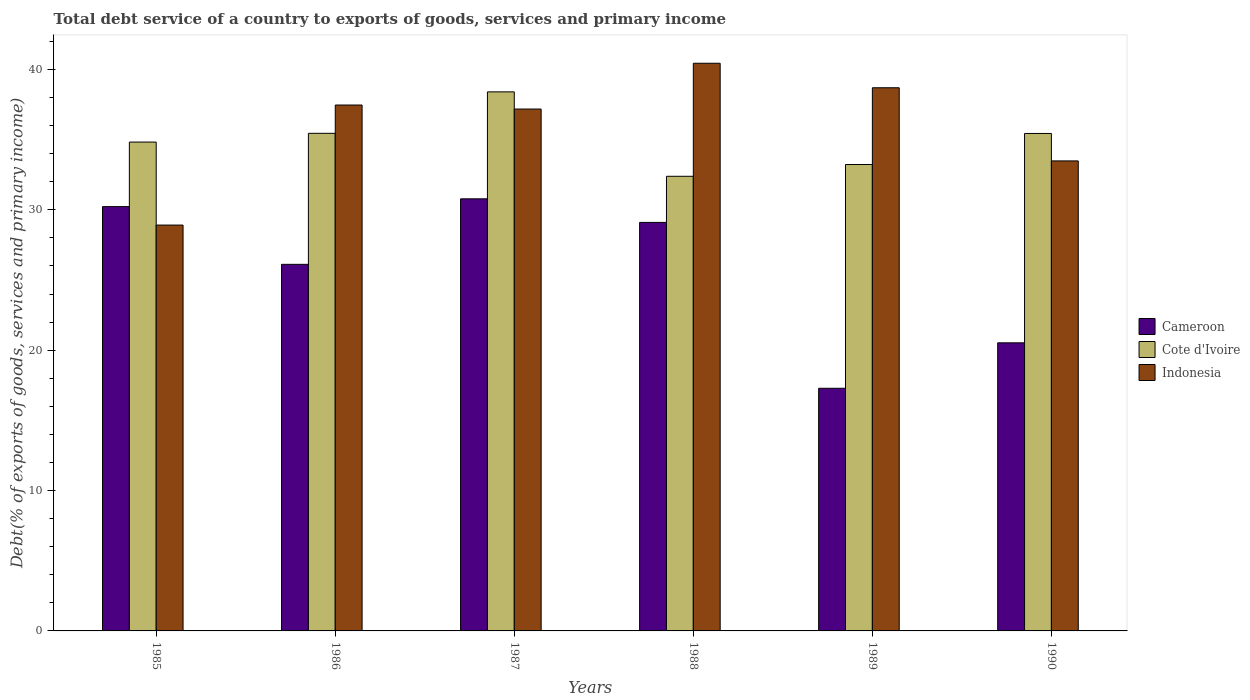How many groups of bars are there?
Your answer should be compact. 6. Are the number of bars per tick equal to the number of legend labels?
Provide a succinct answer. Yes. Are the number of bars on each tick of the X-axis equal?
Provide a short and direct response. Yes. How many bars are there on the 1st tick from the right?
Offer a terse response. 3. What is the total debt service in Indonesia in 1987?
Provide a succinct answer. 37.18. Across all years, what is the maximum total debt service in Cote d'Ivoire?
Your response must be concise. 38.4. Across all years, what is the minimum total debt service in Cameroon?
Offer a very short reply. 17.29. In which year was the total debt service in Cameroon maximum?
Provide a succinct answer. 1987. What is the total total debt service in Indonesia in the graph?
Keep it short and to the point. 216.17. What is the difference between the total debt service in Cameroon in 1985 and that in 1986?
Provide a short and direct response. 4.11. What is the difference between the total debt service in Indonesia in 1987 and the total debt service in Cote d'Ivoire in 1985?
Offer a terse response. 2.35. What is the average total debt service in Indonesia per year?
Provide a succinct answer. 36.03. In the year 1988, what is the difference between the total debt service in Cameroon and total debt service in Indonesia?
Ensure brevity in your answer.  -11.34. What is the ratio of the total debt service in Indonesia in 1986 to that in 1987?
Make the answer very short. 1.01. What is the difference between the highest and the second highest total debt service in Indonesia?
Keep it short and to the point. 1.75. What is the difference between the highest and the lowest total debt service in Cameroon?
Your response must be concise. 13.5. In how many years, is the total debt service in Indonesia greater than the average total debt service in Indonesia taken over all years?
Keep it short and to the point. 4. What does the 1st bar from the left in 1987 represents?
Your answer should be compact. Cameroon. What does the 2nd bar from the right in 1989 represents?
Offer a terse response. Cote d'Ivoire. Is it the case that in every year, the sum of the total debt service in Cote d'Ivoire and total debt service in Cameroon is greater than the total debt service in Indonesia?
Offer a very short reply. Yes. What is the difference between two consecutive major ticks on the Y-axis?
Offer a very short reply. 10. Does the graph contain any zero values?
Your response must be concise. No. Where does the legend appear in the graph?
Your response must be concise. Center right. What is the title of the graph?
Offer a very short reply. Total debt service of a country to exports of goods, services and primary income. Does "Venezuela" appear as one of the legend labels in the graph?
Keep it short and to the point. No. What is the label or title of the Y-axis?
Your answer should be compact. Debt(% of exports of goods, services and primary income). What is the Debt(% of exports of goods, services and primary income) of Cameroon in 1985?
Provide a short and direct response. 30.23. What is the Debt(% of exports of goods, services and primary income) in Cote d'Ivoire in 1985?
Keep it short and to the point. 34.82. What is the Debt(% of exports of goods, services and primary income) in Indonesia in 1985?
Your response must be concise. 28.91. What is the Debt(% of exports of goods, services and primary income) of Cameroon in 1986?
Make the answer very short. 26.11. What is the Debt(% of exports of goods, services and primary income) of Cote d'Ivoire in 1986?
Your response must be concise. 35.45. What is the Debt(% of exports of goods, services and primary income) of Indonesia in 1986?
Offer a very short reply. 37.46. What is the Debt(% of exports of goods, services and primary income) of Cameroon in 1987?
Ensure brevity in your answer.  30.78. What is the Debt(% of exports of goods, services and primary income) of Cote d'Ivoire in 1987?
Your response must be concise. 38.4. What is the Debt(% of exports of goods, services and primary income) in Indonesia in 1987?
Provide a succinct answer. 37.18. What is the Debt(% of exports of goods, services and primary income) in Cameroon in 1988?
Ensure brevity in your answer.  29.1. What is the Debt(% of exports of goods, services and primary income) in Cote d'Ivoire in 1988?
Your response must be concise. 32.39. What is the Debt(% of exports of goods, services and primary income) in Indonesia in 1988?
Your answer should be compact. 40.44. What is the Debt(% of exports of goods, services and primary income) in Cameroon in 1989?
Provide a short and direct response. 17.29. What is the Debt(% of exports of goods, services and primary income) of Cote d'Ivoire in 1989?
Provide a short and direct response. 33.23. What is the Debt(% of exports of goods, services and primary income) of Indonesia in 1989?
Your answer should be very brief. 38.69. What is the Debt(% of exports of goods, services and primary income) in Cameroon in 1990?
Keep it short and to the point. 20.52. What is the Debt(% of exports of goods, services and primary income) in Cote d'Ivoire in 1990?
Make the answer very short. 35.44. What is the Debt(% of exports of goods, services and primary income) of Indonesia in 1990?
Offer a very short reply. 33.48. Across all years, what is the maximum Debt(% of exports of goods, services and primary income) in Cameroon?
Your response must be concise. 30.78. Across all years, what is the maximum Debt(% of exports of goods, services and primary income) in Cote d'Ivoire?
Your answer should be very brief. 38.4. Across all years, what is the maximum Debt(% of exports of goods, services and primary income) in Indonesia?
Make the answer very short. 40.44. Across all years, what is the minimum Debt(% of exports of goods, services and primary income) of Cameroon?
Offer a very short reply. 17.29. Across all years, what is the minimum Debt(% of exports of goods, services and primary income) of Cote d'Ivoire?
Offer a very short reply. 32.39. Across all years, what is the minimum Debt(% of exports of goods, services and primary income) of Indonesia?
Make the answer very short. 28.91. What is the total Debt(% of exports of goods, services and primary income) of Cameroon in the graph?
Your response must be concise. 154.04. What is the total Debt(% of exports of goods, services and primary income) in Cote d'Ivoire in the graph?
Make the answer very short. 209.73. What is the total Debt(% of exports of goods, services and primary income) in Indonesia in the graph?
Offer a terse response. 216.17. What is the difference between the Debt(% of exports of goods, services and primary income) of Cameroon in 1985 and that in 1986?
Your response must be concise. 4.11. What is the difference between the Debt(% of exports of goods, services and primary income) of Cote d'Ivoire in 1985 and that in 1986?
Your response must be concise. -0.62. What is the difference between the Debt(% of exports of goods, services and primary income) of Indonesia in 1985 and that in 1986?
Provide a short and direct response. -8.55. What is the difference between the Debt(% of exports of goods, services and primary income) of Cameroon in 1985 and that in 1987?
Make the answer very short. -0.56. What is the difference between the Debt(% of exports of goods, services and primary income) of Cote d'Ivoire in 1985 and that in 1987?
Offer a terse response. -3.58. What is the difference between the Debt(% of exports of goods, services and primary income) of Indonesia in 1985 and that in 1987?
Keep it short and to the point. -8.27. What is the difference between the Debt(% of exports of goods, services and primary income) in Cameroon in 1985 and that in 1988?
Give a very brief answer. 1.12. What is the difference between the Debt(% of exports of goods, services and primary income) in Cote d'Ivoire in 1985 and that in 1988?
Offer a terse response. 2.44. What is the difference between the Debt(% of exports of goods, services and primary income) in Indonesia in 1985 and that in 1988?
Your response must be concise. -11.53. What is the difference between the Debt(% of exports of goods, services and primary income) in Cameroon in 1985 and that in 1989?
Offer a very short reply. 12.94. What is the difference between the Debt(% of exports of goods, services and primary income) of Cote d'Ivoire in 1985 and that in 1989?
Offer a very short reply. 1.6. What is the difference between the Debt(% of exports of goods, services and primary income) of Indonesia in 1985 and that in 1989?
Ensure brevity in your answer.  -9.78. What is the difference between the Debt(% of exports of goods, services and primary income) in Cameroon in 1985 and that in 1990?
Offer a very short reply. 9.7. What is the difference between the Debt(% of exports of goods, services and primary income) in Cote d'Ivoire in 1985 and that in 1990?
Your answer should be compact. -0.61. What is the difference between the Debt(% of exports of goods, services and primary income) in Indonesia in 1985 and that in 1990?
Your response must be concise. -4.57. What is the difference between the Debt(% of exports of goods, services and primary income) of Cameroon in 1986 and that in 1987?
Keep it short and to the point. -4.67. What is the difference between the Debt(% of exports of goods, services and primary income) of Cote d'Ivoire in 1986 and that in 1987?
Provide a succinct answer. -2.95. What is the difference between the Debt(% of exports of goods, services and primary income) of Indonesia in 1986 and that in 1987?
Keep it short and to the point. 0.29. What is the difference between the Debt(% of exports of goods, services and primary income) of Cameroon in 1986 and that in 1988?
Your answer should be compact. -2.99. What is the difference between the Debt(% of exports of goods, services and primary income) of Cote d'Ivoire in 1986 and that in 1988?
Ensure brevity in your answer.  3.06. What is the difference between the Debt(% of exports of goods, services and primary income) of Indonesia in 1986 and that in 1988?
Keep it short and to the point. -2.98. What is the difference between the Debt(% of exports of goods, services and primary income) in Cameroon in 1986 and that in 1989?
Give a very brief answer. 8.83. What is the difference between the Debt(% of exports of goods, services and primary income) of Cote d'Ivoire in 1986 and that in 1989?
Offer a very short reply. 2.22. What is the difference between the Debt(% of exports of goods, services and primary income) of Indonesia in 1986 and that in 1989?
Keep it short and to the point. -1.23. What is the difference between the Debt(% of exports of goods, services and primary income) of Cameroon in 1986 and that in 1990?
Give a very brief answer. 5.59. What is the difference between the Debt(% of exports of goods, services and primary income) in Cote d'Ivoire in 1986 and that in 1990?
Provide a short and direct response. 0.01. What is the difference between the Debt(% of exports of goods, services and primary income) in Indonesia in 1986 and that in 1990?
Your answer should be very brief. 3.98. What is the difference between the Debt(% of exports of goods, services and primary income) in Cameroon in 1987 and that in 1988?
Provide a short and direct response. 1.68. What is the difference between the Debt(% of exports of goods, services and primary income) in Cote d'Ivoire in 1987 and that in 1988?
Make the answer very short. 6.01. What is the difference between the Debt(% of exports of goods, services and primary income) of Indonesia in 1987 and that in 1988?
Your answer should be very brief. -3.26. What is the difference between the Debt(% of exports of goods, services and primary income) in Cameroon in 1987 and that in 1989?
Give a very brief answer. 13.5. What is the difference between the Debt(% of exports of goods, services and primary income) of Cote d'Ivoire in 1987 and that in 1989?
Offer a very short reply. 5.18. What is the difference between the Debt(% of exports of goods, services and primary income) of Indonesia in 1987 and that in 1989?
Offer a very short reply. -1.52. What is the difference between the Debt(% of exports of goods, services and primary income) in Cameroon in 1987 and that in 1990?
Your response must be concise. 10.26. What is the difference between the Debt(% of exports of goods, services and primary income) of Cote d'Ivoire in 1987 and that in 1990?
Offer a very short reply. 2.96. What is the difference between the Debt(% of exports of goods, services and primary income) in Indonesia in 1987 and that in 1990?
Ensure brevity in your answer.  3.7. What is the difference between the Debt(% of exports of goods, services and primary income) in Cameroon in 1988 and that in 1989?
Provide a short and direct response. 11.82. What is the difference between the Debt(% of exports of goods, services and primary income) in Cote d'Ivoire in 1988 and that in 1989?
Make the answer very short. -0.84. What is the difference between the Debt(% of exports of goods, services and primary income) in Indonesia in 1988 and that in 1989?
Your response must be concise. 1.75. What is the difference between the Debt(% of exports of goods, services and primary income) in Cameroon in 1988 and that in 1990?
Provide a short and direct response. 8.58. What is the difference between the Debt(% of exports of goods, services and primary income) of Cote d'Ivoire in 1988 and that in 1990?
Your answer should be very brief. -3.05. What is the difference between the Debt(% of exports of goods, services and primary income) in Indonesia in 1988 and that in 1990?
Make the answer very short. 6.96. What is the difference between the Debt(% of exports of goods, services and primary income) in Cameroon in 1989 and that in 1990?
Provide a short and direct response. -3.24. What is the difference between the Debt(% of exports of goods, services and primary income) in Cote d'Ivoire in 1989 and that in 1990?
Your response must be concise. -2.21. What is the difference between the Debt(% of exports of goods, services and primary income) of Indonesia in 1989 and that in 1990?
Ensure brevity in your answer.  5.21. What is the difference between the Debt(% of exports of goods, services and primary income) in Cameroon in 1985 and the Debt(% of exports of goods, services and primary income) in Cote d'Ivoire in 1986?
Your response must be concise. -5.22. What is the difference between the Debt(% of exports of goods, services and primary income) in Cameroon in 1985 and the Debt(% of exports of goods, services and primary income) in Indonesia in 1986?
Give a very brief answer. -7.24. What is the difference between the Debt(% of exports of goods, services and primary income) in Cote d'Ivoire in 1985 and the Debt(% of exports of goods, services and primary income) in Indonesia in 1986?
Your answer should be compact. -2.64. What is the difference between the Debt(% of exports of goods, services and primary income) in Cameroon in 1985 and the Debt(% of exports of goods, services and primary income) in Cote d'Ivoire in 1987?
Your answer should be very brief. -8.18. What is the difference between the Debt(% of exports of goods, services and primary income) of Cameroon in 1985 and the Debt(% of exports of goods, services and primary income) of Indonesia in 1987?
Keep it short and to the point. -6.95. What is the difference between the Debt(% of exports of goods, services and primary income) of Cote d'Ivoire in 1985 and the Debt(% of exports of goods, services and primary income) of Indonesia in 1987?
Offer a terse response. -2.35. What is the difference between the Debt(% of exports of goods, services and primary income) in Cameroon in 1985 and the Debt(% of exports of goods, services and primary income) in Cote d'Ivoire in 1988?
Provide a succinct answer. -2.16. What is the difference between the Debt(% of exports of goods, services and primary income) in Cameroon in 1985 and the Debt(% of exports of goods, services and primary income) in Indonesia in 1988?
Your answer should be very brief. -10.21. What is the difference between the Debt(% of exports of goods, services and primary income) of Cote d'Ivoire in 1985 and the Debt(% of exports of goods, services and primary income) of Indonesia in 1988?
Provide a succinct answer. -5.61. What is the difference between the Debt(% of exports of goods, services and primary income) in Cameroon in 1985 and the Debt(% of exports of goods, services and primary income) in Cote d'Ivoire in 1989?
Provide a succinct answer. -3. What is the difference between the Debt(% of exports of goods, services and primary income) in Cameroon in 1985 and the Debt(% of exports of goods, services and primary income) in Indonesia in 1989?
Keep it short and to the point. -8.47. What is the difference between the Debt(% of exports of goods, services and primary income) in Cote d'Ivoire in 1985 and the Debt(% of exports of goods, services and primary income) in Indonesia in 1989?
Offer a terse response. -3.87. What is the difference between the Debt(% of exports of goods, services and primary income) of Cameroon in 1985 and the Debt(% of exports of goods, services and primary income) of Cote d'Ivoire in 1990?
Your answer should be compact. -5.21. What is the difference between the Debt(% of exports of goods, services and primary income) in Cameroon in 1985 and the Debt(% of exports of goods, services and primary income) in Indonesia in 1990?
Offer a terse response. -3.26. What is the difference between the Debt(% of exports of goods, services and primary income) in Cote d'Ivoire in 1985 and the Debt(% of exports of goods, services and primary income) in Indonesia in 1990?
Provide a succinct answer. 1.34. What is the difference between the Debt(% of exports of goods, services and primary income) of Cameroon in 1986 and the Debt(% of exports of goods, services and primary income) of Cote d'Ivoire in 1987?
Offer a terse response. -12.29. What is the difference between the Debt(% of exports of goods, services and primary income) of Cameroon in 1986 and the Debt(% of exports of goods, services and primary income) of Indonesia in 1987?
Provide a short and direct response. -11.06. What is the difference between the Debt(% of exports of goods, services and primary income) in Cote d'Ivoire in 1986 and the Debt(% of exports of goods, services and primary income) in Indonesia in 1987?
Your response must be concise. -1.73. What is the difference between the Debt(% of exports of goods, services and primary income) in Cameroon in 1986 and the Debt(% of exports of goods, services and primary income) in Cote d'Ivoire in 1988?
Ensure brevity in your answer.  -6.27. What is the difference between the Debt(% of exports of goods, services and primary income) in Cameroon in 1986 and the Debt(% of exports of goods, services and primary income) in Indonesia in 1988?
Offer a very short reply. -14.32. What is the difference between the Debt(% of exports of goods, services and primary income) of Cote d'Ivoire in 1986 and the Debt(% of exports of goods, services and primary income) of Indonesia in 1988?
Provide a short and direct response. -4.99. What is the difference between the Debt(% of exports of goods, services and primary income) in Cameroon in 1986 and the Debt(% of exports of goods, services and primary income) in Cote d'Ivoire in 1989?
Offer a very short reply. -7.11. What is the difference between the Debt(% of exports of goods, services and primary income) of Cameroon in 1986 and the Debt(% of exports of goods, services and primary income) of Indonesia in 1989?
Provide a succinct answer. -12.58. What is the difference between the Debt(% of exports of goods, services and primary income) in Cote d'Ivoire in 1986 and the Debt(% of exports of goods, services and primary income) in Indonesia in 1989?
Ensure brevity in your answer.  -3.25. What is the difference between the Debt(% of exports of goods, services and primary income) in Cameroon in 1986 and the Debt(% of exports of goods, services and primary income) in Cote d'Ivoire in 1990?
Make the answer very short. -9.32. What is the difference between the Debt(% of exports of goods, services and primary income) in Cameroon in 1986 and the Debt(% of exports of goods, services and primary income) in Indonesia in 1990?
Your answer should be very brief. -7.37. What is the difference between the Debt(% of exports of goods, services and primary income) in Cote d'Ivoire in 1986 and the Debt(% of exports of goods, services and primary income) in Indonesia in 1990?
Provide a short and direct response. 1.97. What is the difference between the Debt(% of exports of goods, services and primary income) in Cameroon in 1987 and the Debt(% of exports of goods, services and primary income) in Cote d'Ivoire in 1988?
Keep it short and to the point. -1.6. What is the difference between the Debt(% of exports of goods, services and primary income) of Cameroon in 1987 and the Debt(% of exports of goods, services and primary income) of Indonesia in 1988?
Your response must be concise. -9.66. What is the difference between the Debt(% of exports of goods, services and primary income) in Cote d'Ivoire in 1987 and the Debt(% of exports of goods, services and primary income) in Indonesia in 1988?
Keep it short and to the point. -2.04. What is the difference between the Debt(% of exports of goods, services and primary income) of Cameroon in 1987 and the Debt(% of exports of goods, services and primary income) of Cote d'Ivoire in 1989?
Offer a very short reply. -2.44. What is the difference between the Debt(% of exports of goods, services and primary income) in Cameroon in 1987 and the Debt(% of exports of goods, services and primary income) in Indonesia in 1989?
Offer a very short reply. -7.91. What is the difference between the Debt(% of exports of goods, services and primary income) of Cote d'Ivoire in 1987 and the Debt(% of exports of goods, services and primary income) of Indonesia in 1989?
Offer a terse response. -0.29. What is the difference between the Debt(% of exports of goods, services and primary income) in Cameroon in 1987 and the Debt(% of exports of goods, services and primary income) in Cote d'Ivoire in 1990?
Provide a short and direct response. -4.66. What is the difference between the Debt(% of exports of goods, services and primary income) of Cameroon in 1987 and the Debt(% of exports of goods, services and primary income) of Indonesia in 1990?
Give a very brief answer. -2.7. What is the difference between the Debt(% of exports of goods, services and primary income) of Cote d'Ivoire in 1987 and the Debt(% of exports of goods, services and primary income) of Indonesia in 1990?
Ensure brevity in your answer.  4.92. What is the difference between the Debt(% of exports of goods, services and primary income) of Cameroon in 1988 and the Debt(% of exports of goods, services and primary income) of Cote d'Ivoire in 1989?
Your response must be concise. -4.12. What is the difference between the Debt(% of exports of goods, services and primary income) of Cameroon in 1988 and the Debt(% of exports of goods, services and primary income) of Indonesia in 1989?
Ensure brevity in your answer.  -9.59. What is the difference between the Debt(% of exports of goods, services and primary income) in Cote d'Ivoire in 1988 and the Debt(% of exports of goods, services and primary income) in Indonesia in 1989?
Keep it short and to the point. -6.31. What is the difference between the Debt(% of exports of goods, services and primary income) in Cameroon in 1988 and the Debt(% of exports of goods, services and primary income) in Cote d'Ivoire in 1990?
Your response must be concise. -6.33. What is the difference between the Debt(% of exports of goods, services and primary income) in Cameroon in 1988 and the Debt(% of exports of goods, services and primary income) in Indonesia in 1990?
Offer a terse response. -4.38. What is the difference between the Debt(% of exports of goods, services and primary income) in Cote d'Ivoire in 1988 and the Debt(% of exports of goods, services and primary income) in Indonesia in 1990?
Keep it short and to the point. -1.1. What is the difference between the Debt(% of exports of goods, services and primary income) of Cameroon in 1989 and the Debt(% of exports of goods, services and primary income) of Cote d'Ivoire in 1990?
Your answer should be compact. -18.15. What is the difference between the Debt(% of exports of goods, services and primary income) of Cameroon in 1989 and the Debt(% of exports of goods, services and primary income) of Indonesia in 1990?
Offer a very short reply. -16.2. What is the difference between the Debt(% of exports of goods, services and primary income) of Cote d'Ivoire in 1989 and the Debt(% of exports of goods, services and primary income) of Indonesia in 1990?
Offer a very short reply. -0.26. What is the average Debt(% of exports of goods, services and primary income) of Cameroon per year?
Your answer should be compact. 25.67. What is the average Debt(% of exports of goods, services and primary income) in Cote d'Ivoire per year?
Make the answer very short. 34.95. What is the average Debt(% of exports of goods, services and primary income) in Indonesia per year?
Provide a short and direct response. 36.03. In the year 1985, what is the difference between the Debt(% of exports of goods, services and primary income) of Cameroon and Debt(% of exports of goods, services and primary income) of Cote d'Ivoire?
Offer a terse response. -4.6. In the year 1985, what is the difference between the Debt(% of exports of goods, services and primary income) in Cameroon and Debt(% of exports of goods, services and primary income) in Indonesia?
Offer a very short reply. 1.31. In the year 1985, what is the difference between the Debt(% of exports of goods, services and primary income) in Cote d'Ivoire and Debt(% of exports of goods, services and primary income) in Indonesia?
Ensure brevity in your answer.  5.91. In the year 1986, what is the difference between the Debt(% of exports of goods, services and primary income) of Cameroon and Debt(% of exports of goods, services and primary income) of Cote d'Ivoire?
Your answer should be compact. -9.33. In the year 1986, what is the difference between the Debt(% of exports of goods, services and primary income) of Cameroon and Debt(% of exports of goods, services and primary income) of Indonesia?
Provide a succinct answer. -11.35. In the year 1986, what is the difference between the Debt(% of exports of goods, services and primary income) in Cote d'Ivoire and Debt(% of exports of goods, services and primary income) in Indonesia?
Provide a short and direct response. -2.02. In the year 1987, what is the difference between the Debt(% of exports of goods, services and primary income) in Cameroon and Debt(% of exports of goods, services and primary income) in Cote d'Ivoire?
Offer a very short reply. -7.62. In the year 1987, what is the difference between the Debt(% of exports of goods, services and primary income) in Cameroon and Debt(% of exports of goods, services and primary income) in Indonesia?
Your answer should be compact. -6.4. In the year 1987, what is the difference between the Debt(% of exports of goods, services and primary income) of Cote d'Ivoire and Debt(% of exports of goods, services and primary income) of Indonesia?
Keep it short and to the point. 1.22. In the year 1988, what is the difference between the Debt(% of exports of goods, services and primary income) of Cameroon and Debt(% of exports of goods, services and primary income) of Cote d'Ivoire?
Your answer should be very brief. -3.28. In the year 1988, what is the difference between the Debt(% of exports of goods, services and primary income) in Cameroon and Debt(% of exports of goods, services and primary income) in Indonesia?
Your response must be concise. -11.34. In the year 1988, what is the difference between the Debt(% of exports of goods, services and primary income) of Cote d'Ivoire and Debt(% of exports of goods, services and primary income) of Indonesia?
Keep it short and to the point. -8.05. In the year 1989, what is the difference between the Debt(% of exports of goods, services and primary income) of Cameroon and Debt(% of exports of goods, services and primary income) of Cote d'Ivoire?
Offer a terse response. -15.94. In the year 1989, what is the difference between the Debt(% of exports of goods, services and primary income) of Cameroon and Debt(% of exports of goods, services and primary income) of Indonesia?
Offer a very short reply. -21.41. In the year 1989, what is the difference between the Debt(% of exports of goods, services and primary income) in Cote d'Ivoire and Debt(% of exports of goods, services and primary income) in Indonesia?
Keep it short and to the point. -5.47. In the year 1990, what is the difference between the Debt(% of exports of goods, services and primary income) in Cameroon and Debt(% of exports of goods, services and primary income) in Cote d'Ivoire?
Your answer should be very brief. -14.91. In the year 1990, what is the difference between the Debt(% of exports of goods, services and primary income) of Cameroon and Debt(% of exports of goods, services and primary income) of Indonesia?
Give a very brief answer. -12.96. In the year 1990, what is the difference between the Debt(% of exports of goods, services and primary income) in Cote d'Ivoire and Debt(% of exports of goods, services and primary income) in Indonesia?
Provide a succinct answer. 1.96. What is the ratio of the Debt(% of exports of goods, services and primary income) in Cameroon in 1985 to that in 1986?
Ensure brevity in your answer.  1.16. What is the ratio of the Debt(% of exports of goods, services and primary income) in Cote d'Ivoire in 1985 to that in 1986?
Offer a terse response. 0.98. What is the ratio of the Debt(% of exports of goods, services and primary income) of Indonesia in 1985 to that in 1986?
Provide a succinct answer. 0.77. What is the ratio of the Debt(% of exports of goods, services and primary income) of Cameroon in 1985 to that in 1987?
Provide a short and direct response. 0.98. What is the ratio of the Debt(% of exports of goods, services and primary income) of Cote d'Ivoire in 1985 to that in 1987?
Your answer should be compact. 0.91. What is the ratio of the Debt(% of exports of goods, services and primary income) of Indonesia in 1985 to that in 1987?
Give a very brief answer. 0.78. What is the ratio of the Debt(% of exports of goods, services and primary income) in Cameroon in 1985 to that in 1988?
Make the answer very short. 1.04. What is the ratio of the Debt(% of exports of goods, services and primary income) in Cote d'Ivoire in 1985 to that in 1988?
Your answer should be compact. 1.08. What is the ratio of the Debt(% of exports of goods, services and primary income) of Indonesia in 1985 to that in 1988?
Make the answer very short. 0.71. What is the ratio of the Debt(% of exports of goods, services and primary income) of Cameroon in 1985 to that in 1989?
Your answer should be very brief. 1.75. What is the ratio of the Debt(% of exports of goods, services and primary income) of Cote d'Ivoire in 1985 to that in 1989?
Make the answer very short. 1.05. What is the ratio of the Debt(% of exports of goods, services and primary income) in Indonesia in 1985 to that in 1989?
Provide a succinct answer. 0.75. What is the ratio of the Debt(% of exports of goods, services and primary income) in Cameroon in 1985 to that in 1990?
Your answer should be compact. 1.47. What is the ratio of the Debt(% of exports of goods, services and primary income) of Cote d'Ivoire in 1985 to that in 1990?
Provide a short and direct response. 0.98. What is the ratio of the Debt(% of exports of goods, services and primary income) of Indonesia in 1985 to that in 1990?
Offer a very short reply. 0.86. What is the ratio of the Debt(% of exports of goods, services and primary income) in Cameroon in 1986 to that in 1987?
Offer a very short reply. 0.85. What is the ratio of the Debt(% of exports of goods, services and primary income) of Indonesia in 1986 to that in 1987?
Ensure brevity in your answer.  1.01. What is the ratio of the Debt(% of exports of goods, services and primary income) of Cameroon in 1986 to that in 1988?
Provide a succinct answer. 0.9. What is the ratio of the Debt(% of exports of goods, services and primary income) in Cote d'Ivoire in 1986 to that in 1988?
Provide a short and direct response. 1.09. What is the ratio of the Debt(% of exports of goods, services and primary income) of Indonesia in 1986 to that in 1988?
Make the answer very short. 0.93. What is the ratio of the Debt(% of exports of goods, services and primary income) of Cameroon in 1986 to that in 1989?
Ensure brevity in your answer.  1.51. What is the ratio of the Debt(% of exports of goods, services and primary income) in Cote d'Ivoire in 1986 to that in 1989?
Keep it short and to the point. 1.07. What is the ratio of the Debt(% of exports of goods, services and primary income) in Indonesia in 1986 to that in 1989?
Your answer should be compact. 0.97. What is the ratio of the Debt(% of exports of goods, services and primary income) of Cameroon in 1986 to that in 1990?
Offer a terse response. 1.27. What is the ratio of the Debt(% of exports of goods, services and primary income) in Indonesia in 1986 to that in 1990?
Provide a short and direct response. 1.12. What is the ratio of the Debt(% of exports of goods, services and primary income) of Cameroon in 1987 to that in 1988?
Your answer should be very brief. 1.06. What is the ratio of the Debt(% of exports of goods, services and primary income) in Cote d'Ivoire in 1987 to that in 1988?
Your answer should be compact. 1.19. What is the ratio of the Debt(% of exports of goods, services and primary income) of Indonesia in 1987 to that in 1988?
Your response must be concise. 0.92. What is the ratio of the Debt(% of exports of goods, services and primary income) in Cameroon in 1987 to that in 1989?
Keep it short and to the point. 1.78. What is the ratio of the Debt(% of exports of goods, services and primary income) in Cote d'Ivoire in 1987 to that in 1989?
Ensure brevity in your answer.  1.16. What is the ratio of the Debt(% of exports of goods, services and primary income) in Indonesia in 1987 to that in 1989?
Ensure brevity in your answer.  0.96. What is the ratio of the Debt(% of exports of goods, services and primary income) of Cameroon in 1987 to that in 1990?
Offer a very short reply. 1.5. What is the ratio of the Debt(% of exports of goods, services and primary income) of Cote d'Ivoire in 1987 to that in 1990?
Ensure brevity in your answer.  1.08. What is the ratio of the Debt(% of exports of goods, services and primary income) in Indonesia in 1987 to that in 1990?
Your answer should be compact. 1.11. What is the ratio of the Debt(% of exports of goods, services and primary income) in Cameroon in 1988 to that in 1989?
Provide a succinct answer. 1.68. What is the ratio of the Debt(% of exports of goods, services and primary income) of Cote d'Ivoire in 1988 to that in 1989?
Offer a very short reply. 0.97. What is the ratio of the Debt(% of exports of goods, services and primary income) of Indonesia in 1988 to that in 1989?
Make the answer very short. 1.05. What is the ratio of the Debt(% of exports of goods, services and primary income) of Cameroon in 1988 to that in 1990?
Provide a succinct answer. 1.42. What is the ratio of the Debt(% of exports of goods, services and primary income) of Cote d'Ivoire in 1988 to that in 1990?
Offer a very short reply. 0.91. What is the ratio of the Debt(% of exports of goods, services and primary income) in Indonesia in 1988 to that in 1990?
Offer a terse response. 1.21. What is the ratio of the Debt(% of exports of goods, services and primary income) in Cameroon in 1989 to that in 1990?
Offer a terse response. 0.84. What is the ratio of the Debt(% of exports of goods, services and primary income) of Cote d'Ivoire in 1989 to that in 1990?
Your answer should be compact. 0.94. What is the ratio of the Debt(% of exports of goods, services and primary income) of Indonesia in 1989 to that in 1990?
Keep it short and to the point. 1.16. What is the difference between the highest and the second highest Debt(% of exports of goods, services and primary income) in Cameroon?
Your answer should be compact. 0.56. What is the difference between the highest and the second highest Debt(% of exports of goods, services and primary income) of Cote d'Ivoire?
Your answer should be compact. 2.95. What is the difference between the highest and the second highest Debt(% of exports of goods, services and primary income) in Indonesia?
Ensure brevity in your answer.  1.75. What is the difference between the highest and the lowest Debt(% of exports of goods, services and primary income) of Cameroon?
Provide a short and direct response. 13.5. What is the difference between the highest and the lowest Debt(% of exports of goods, services and primary income) of Cote d'Ivoire?
Ensure brevity in your answer.  6.01. What is the difference between the highest and the lowest Debt(% of exports of goods, services and primary income) in Indonesia?
Provide a succinct answer. 11.53. 